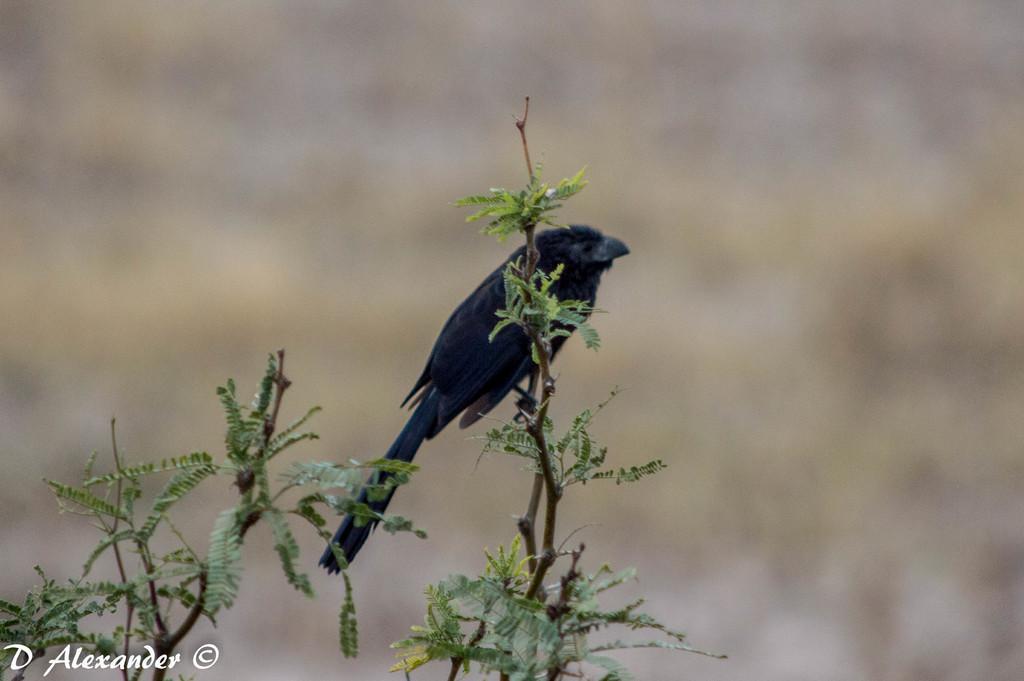Describe this image in one or two sentences. In this image image there is a bird standing on a stem of a plant. There are leaves to the stems. The background is blurry. In the bottom left there is text on the image. 